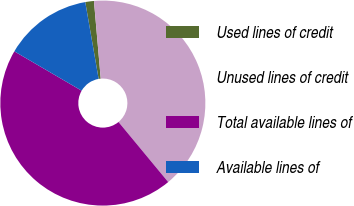Convert chart to OTSL. <chart><loc_0><loc_0><loc_500><loc_500><pie_chart><fcel>Used lines of credit<fcel>Unused lines of credit<fcel>Total available lines of<fcel>Available lines of<nl><fcel>1.36%<fcel>40.38%<fcel>44.42%<fcel>13.84%<nl></chart> 